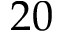Convert formula to latex. <formula><loc_0><loc_0><loc_500><loc_500>2 0</formula> 